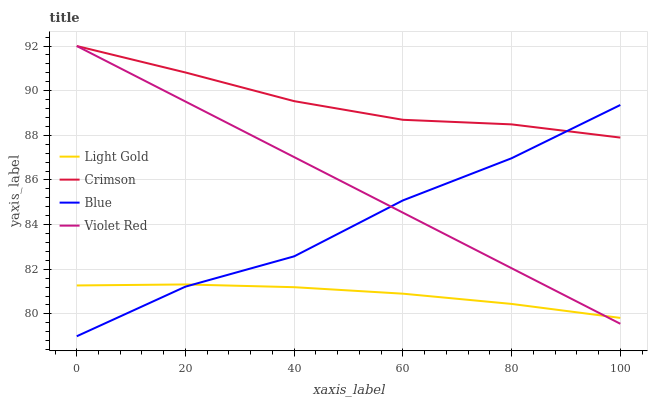Does Light Gold have the minimum area under the curve?
Answer yes or no. Yes. Does Crimson have the maximum area under the curve?
Answer yes or no. Yes. Does Blue have the minimum area under the curve?
Answer yes or no. No. Does Blue have the maximum area under the curve?
Answer yes or no. No. Is Violet Red the smoothest?
Answer yes or no. Yes. Is Blue the roughest?
Answer yes or no. Yes. Is Blue the smoothest?
Answer yes or no. No. Is Violet Red the roughest?
Answer yes or no. No. Does Violet Red have the lowest value?
Answer yes or no. No. Does Violet Red have the highest value?
Answer yes or no. Yes. Does Blue have the highest value?
Answer yes or no. No. Is Light Gold less than Crimson?
Answer yes or no. Yes. Is Crimson greater than Light Gold?
Answer yes or no. Yes. Does Violet Red intersect Crimson?
Answer yes or no. Yes. Is Violet Red less than Crimson?
Answer yes or no. No. Is Violet Red greater than Crimson?
Answer yes or no. No. Does Light Gold intersect Crimson?
Answer yes or no. No. 